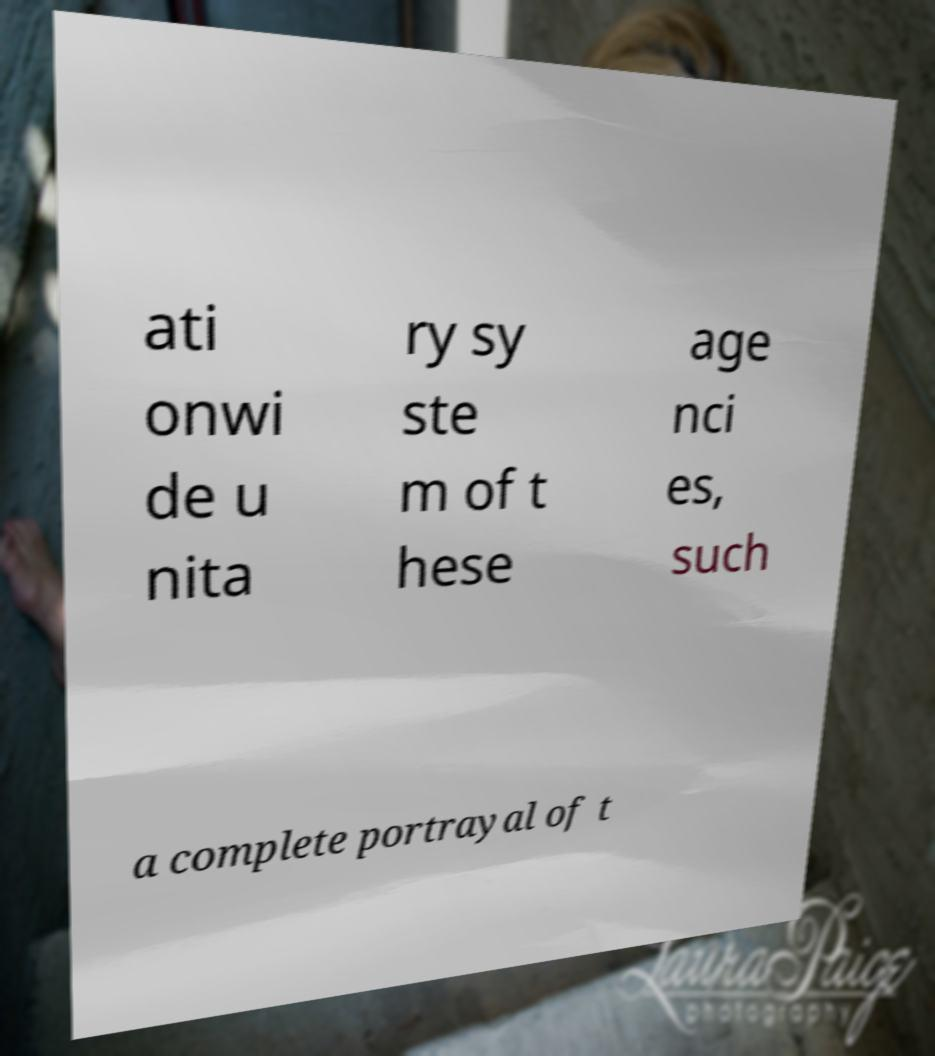Can you accurately transcribe the text from the provided image for me? ati onwi de u nita ry sy ste m of t hese age nci es, such a complete portrayal of t 